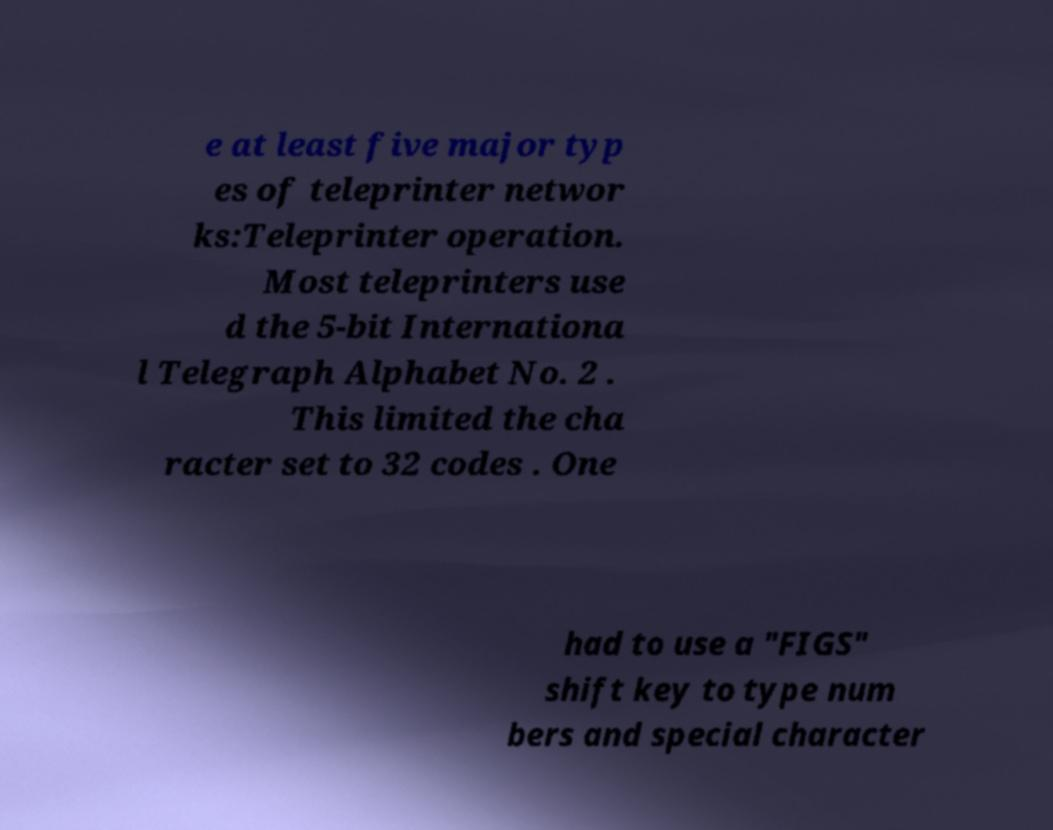Please read and relay the text visible in this image. What does it say? e at least five major typ es of teleprinter networ ks:Teleprinter operation. Most teleprinters use d the 5-bit Internationa l Telegraph Alphabet No. 2 . This limited the cha racter set to 32 codes . One had to use a "FIGS" shift key to type num bers and special character 